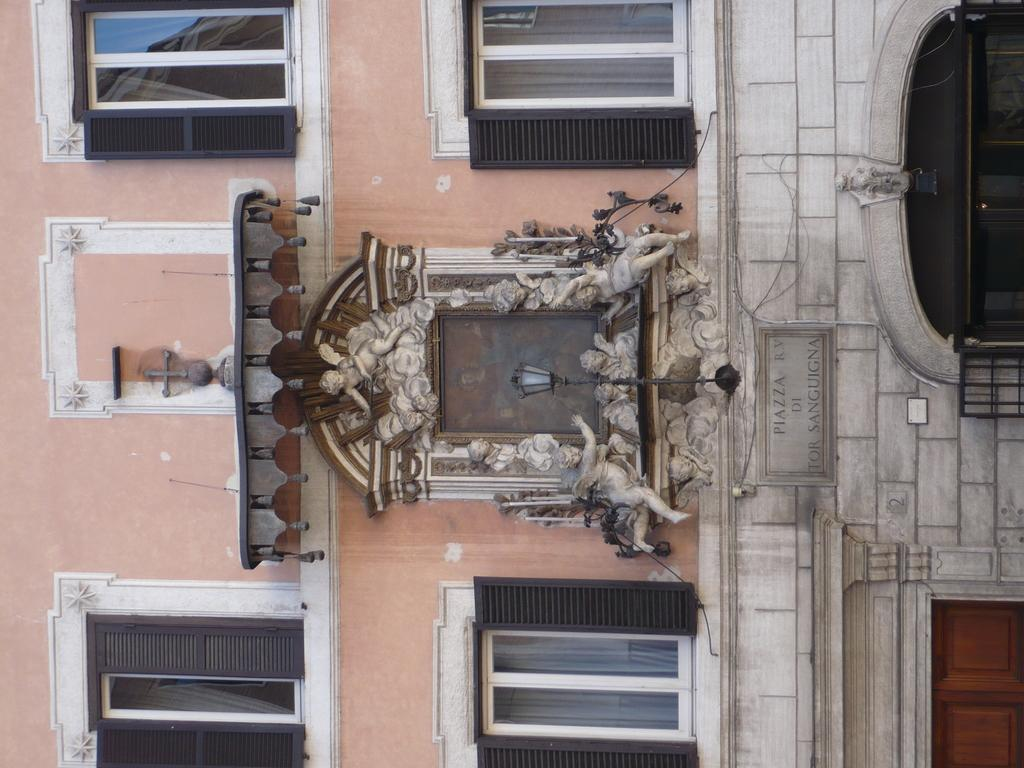What type of structure is shown in the image? There is a building in the image. How is the building oriented in the image? The building is depicted in a vertical direction. How many windows are visible on the building? There are four windows on the building. Is there any illumination source on the building? Yes, there is a light in the center of the building. What type of hole can be seen in the building in the image? There is no hole present in the building in the image. 